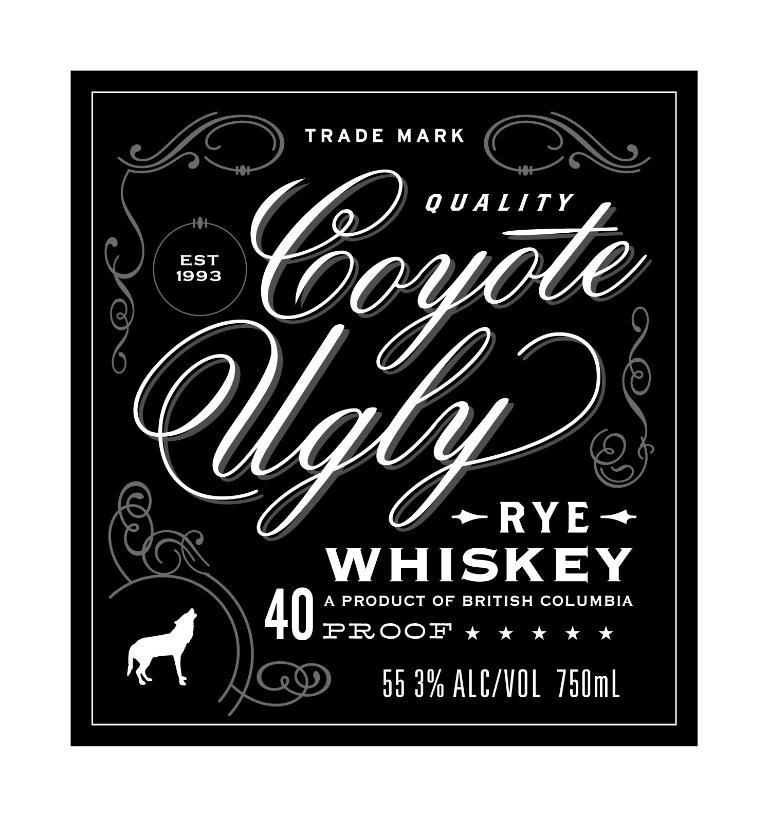<image>
Describe the image concisely. A label for Quality Coyote Ugly Rye Whiskey. 